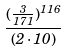<formula> <loc_0><loc_0><loc_500><loc_500>\frac { ( \frac { 3 } { 1 7 1 } ) ^ { 1 1 6 } } { ( 2 \cdot 1 0 ) }</formula> 